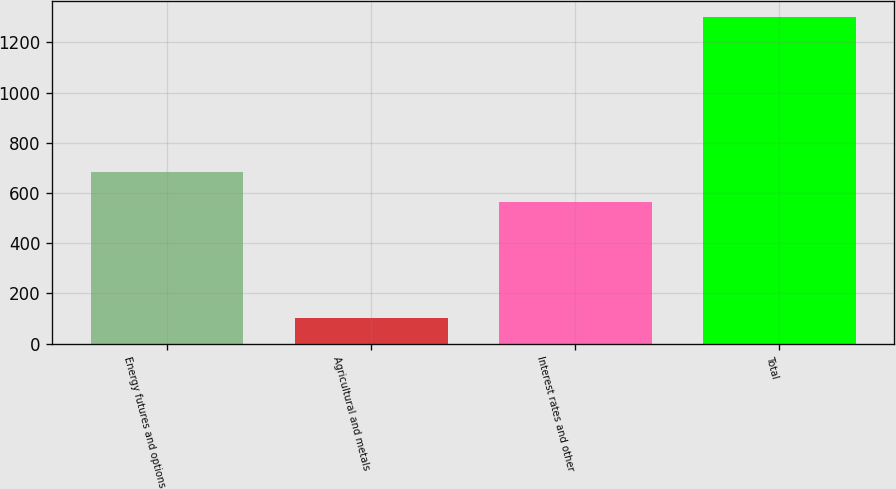<chart> <loc_0><loc_0><loc_500><loc_500><bar_chart><fcel>Energy futures and options<fcel>Agricultural and metals<fcel>Interest rates and other<fcel>Total<nl><fcel>683.9<fcel>101<fcel>564<fcel>1300<nl></chart> 